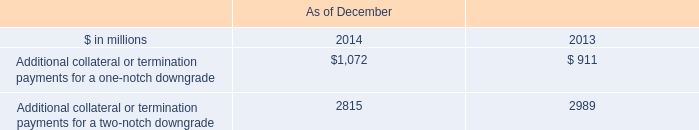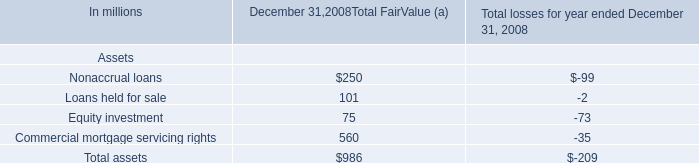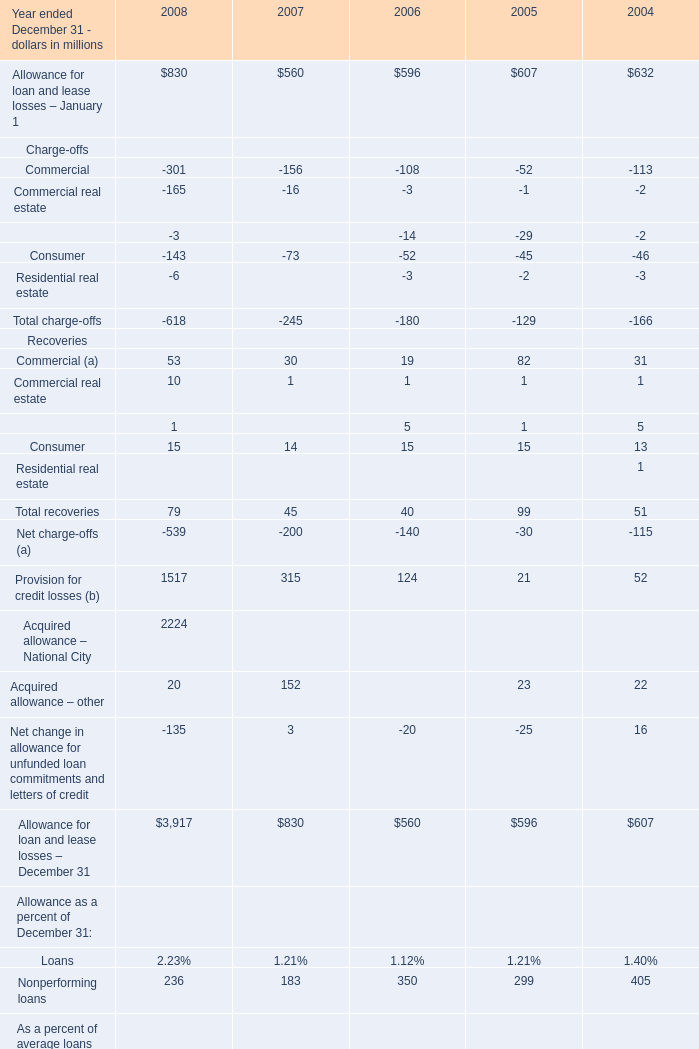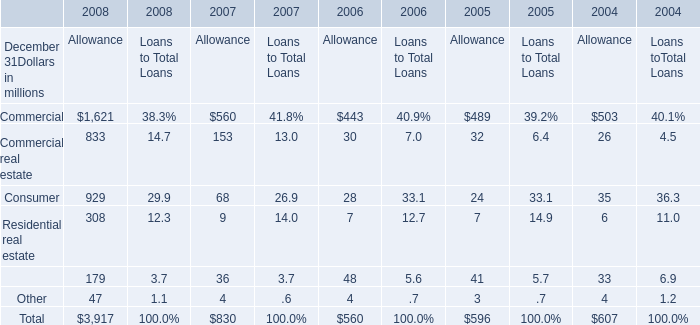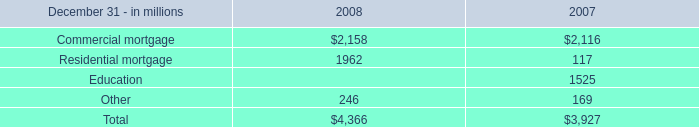What's the growth rate of Commercial (a) in 2008? (in %) 
Computations: ((53 - 30) / 30)
Answer: 0.76667. 